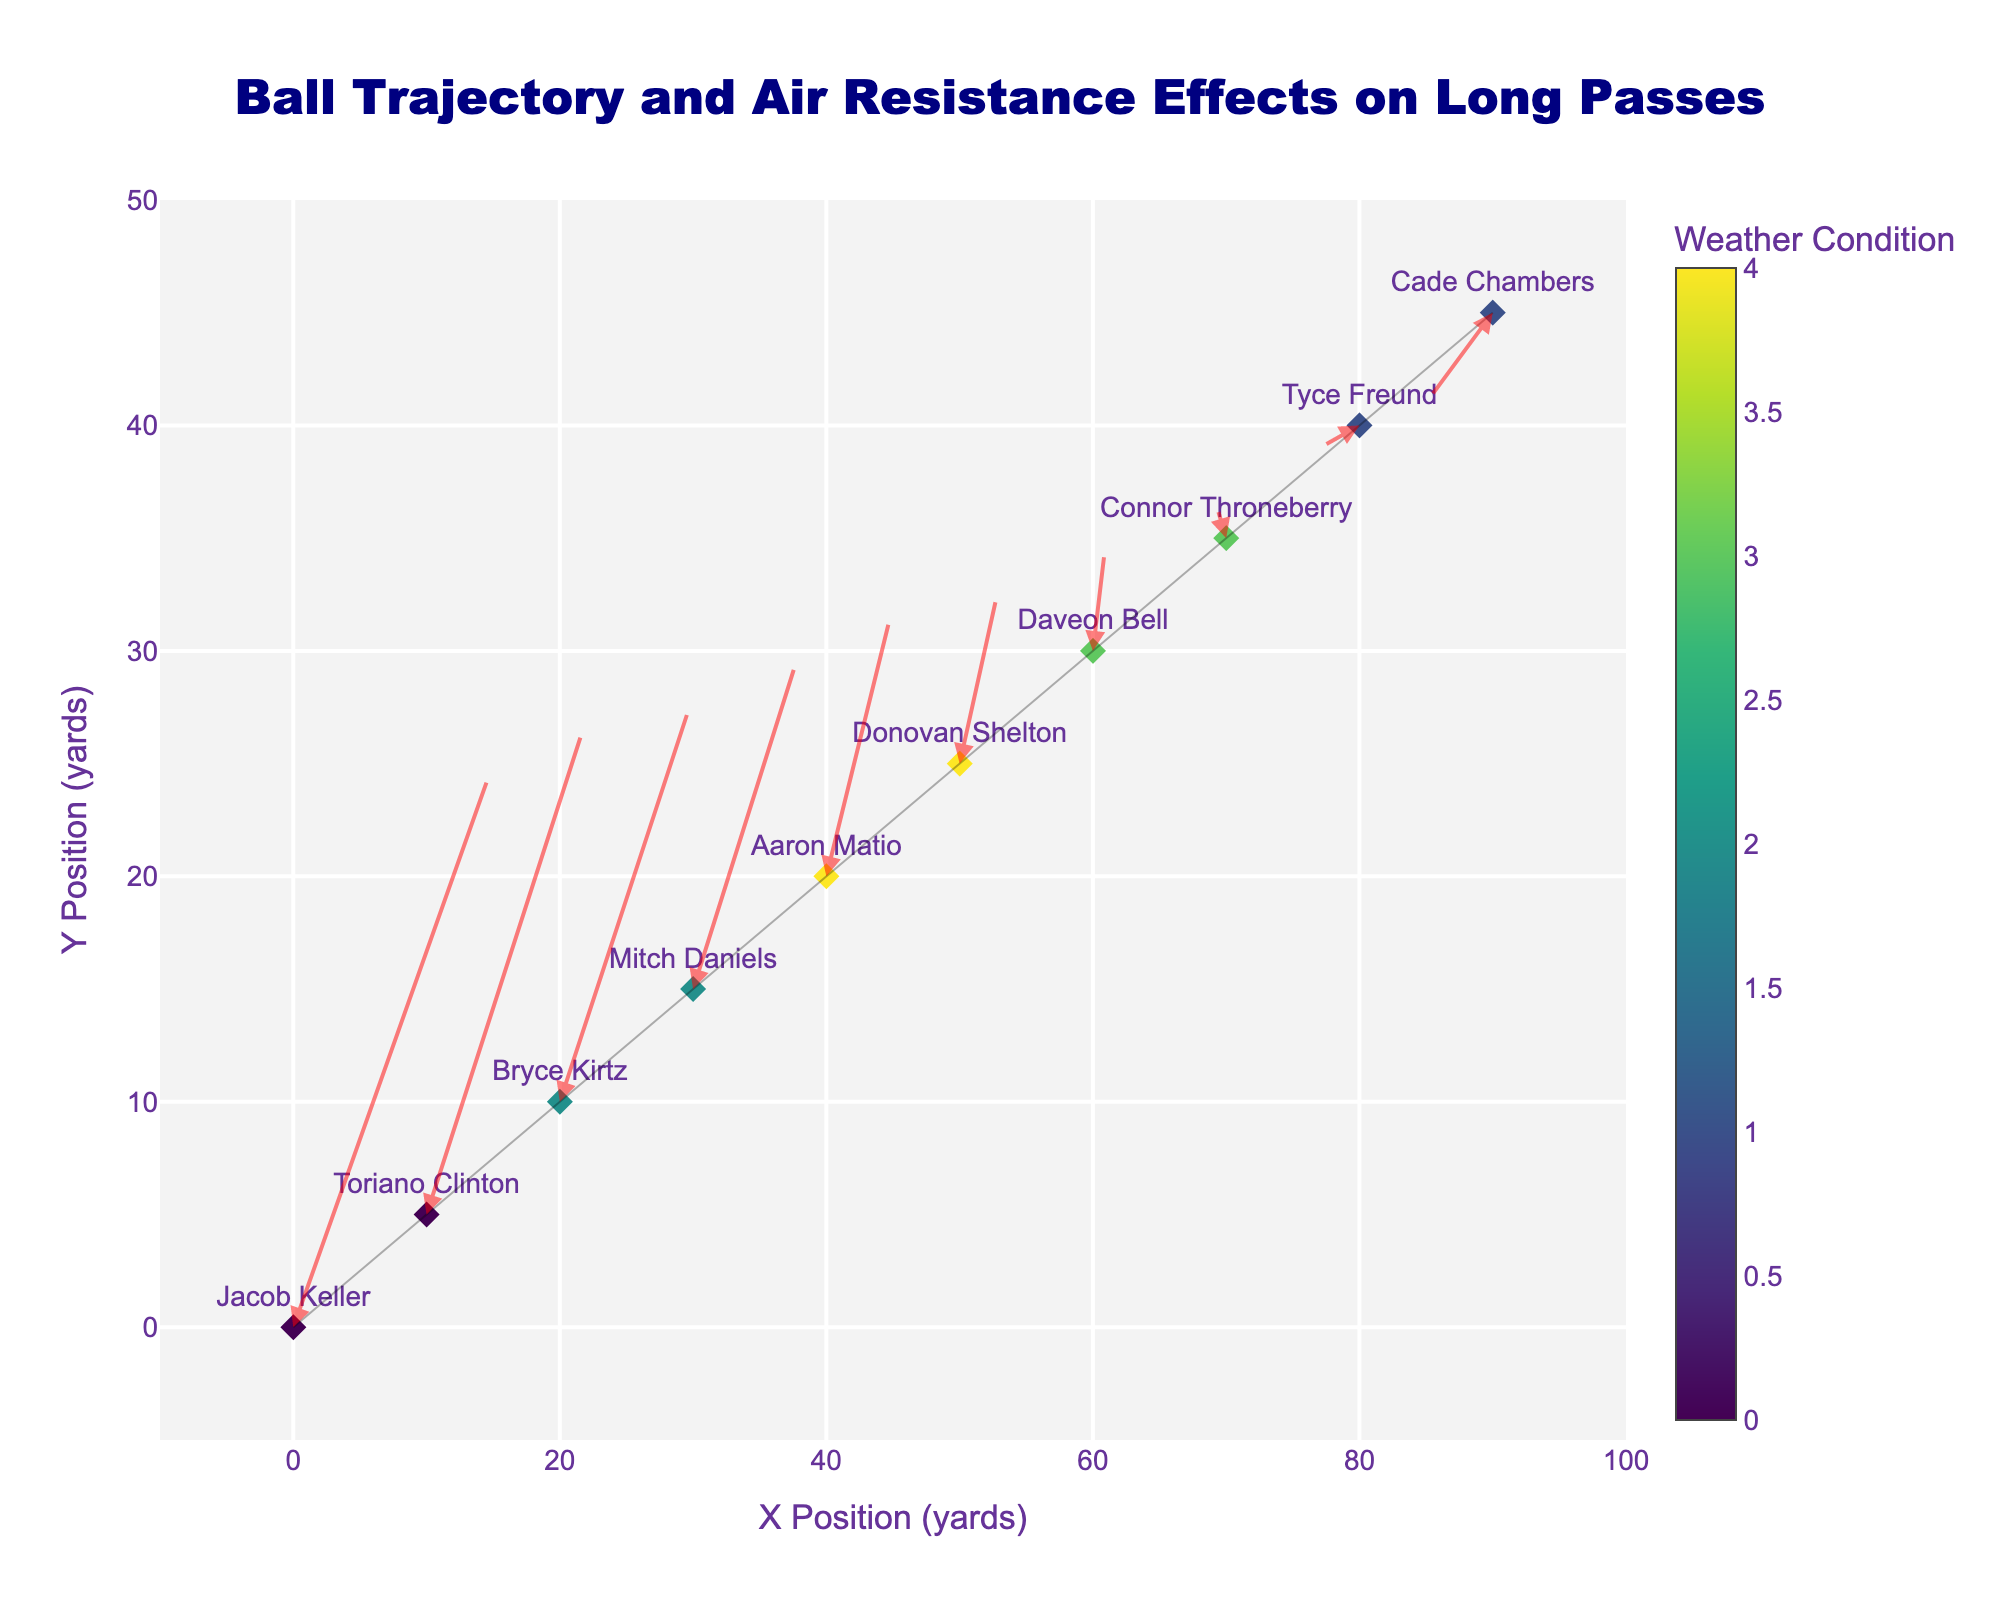What's the title of the figure? The title is displayed at the top center of the figure. It reads "Ball Trajectory and Air Resistance Effects on Long Passes".
Answer: Ball Trajectory and Air Resistance Effects on Long Passes How many weather conditions are shown in the figure? Each color in the scatter plot represents a different weather condition. The color bar can be used to count the distinct weather conditions: Clear, Light Rain, Windy, Snowy, and Foggy.
Answer: 5 Which player has their pass end up in the negative y direction? Look for the arrow where the end point, determined by the components u and v, lies below the x-axis. This happens for Tyce Freund during Foggy weather, as indicated by the arrow pointing to y = -1.
Answer: Tyce Freund What is the x-coordinate of the ball position by the time it reaches -1 in the y coordinate? Identifying Tyce Freund’s arrow, which ends at -1 in the y-axis, the starting x-coordinate for this arrow is 80, and adding the u component (-3) to it results in 77.
Answer: 77 Compare the magnitude of the wind effect between Clear and Snowy weather For Clear weather, examine the arrows from Jacob Keller and Toriano Clinton who have larger u and v components (15, 25) and (12, 22), respectively. For Snowy weather, Daveon Bell and Connor Throneberry have smaller u and v components (1, 5) and (-1, 2). Thus, the effect is greater during Clear weather.
Answer: Greater during Clear weather Which weather condition seems to have the most significant negative impact on the trajectory? By identifying the directions of the arrows (negative u and v components) and their lengths, one can see that Foggy weather, with Cade Chambers having a substantial negative arrow (-5, -4), affects the trajectory the most.
Answer: Foggy What are the closest starting positions (x and y) between Jacob Keller and Bryce Kirtz? Jacob's position is at (0, 0) and Bryce's position is at (20, 10). Calculate the Euclidean distance √((20-0)² + (10-0)²) = √500 ≈ 22.36 yards.
Answer: 22.36 yards Which player has the longest pass in Clear weather? Compare the lengths of arrows for players in Clear weather: Jacob Keller (√(15²+25²) ≈ 29.15) versus Toriano Clinton (√(12²+22²) ≈ 25.94). Jacob Keller's pass is longer.
Answer: Jacob Keller What is the average y-component for passes in Windy weather? Calculate the average of the y-components (12 and 8) of passes by Aaron Matio and Donovan Shelton. (12 + 8) / 2 = 10.
Answer: 10 For the player in Snowy weather located initially at (60, 30), what is their final position? Find the initial x and y values, then add the respective u and v components (1, 5) to obtain the final position. (60 + 1, 30 + 5) = (61, 35).
Answer: (61, 35) 